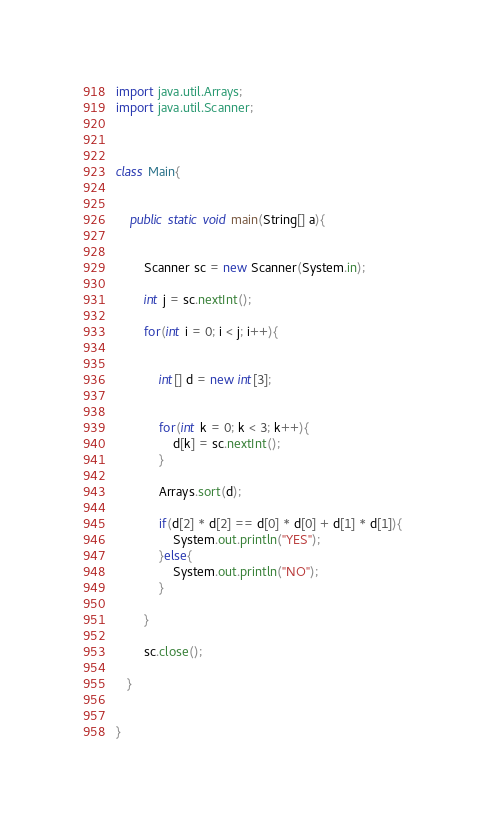<code> <loc_0><loc_0><loc_500><loc_500><_Java_>import java.util.Arrays;
import java.util.Scanner;



class Main{


    public static void main(String[] a){


        Scanner sc = new Scanner(System.in);

        int j = sc.nextInt();

        for(int i = 0; i < j; i++){


        	int[] d = new int[3];


        	for(int k = 0; k < 3; k++){
	        	d[k] = sc.nextInt();
	        }

        	Arrays.sort(d);

        	if(d[2] * d[2] == d[0] * d[0] + d[1] * d[1]){
        		System.out.println("YES");
        	}else{
        		System.out.println("NO");
        	}

        }

        sc.close();

   }


}</code> 